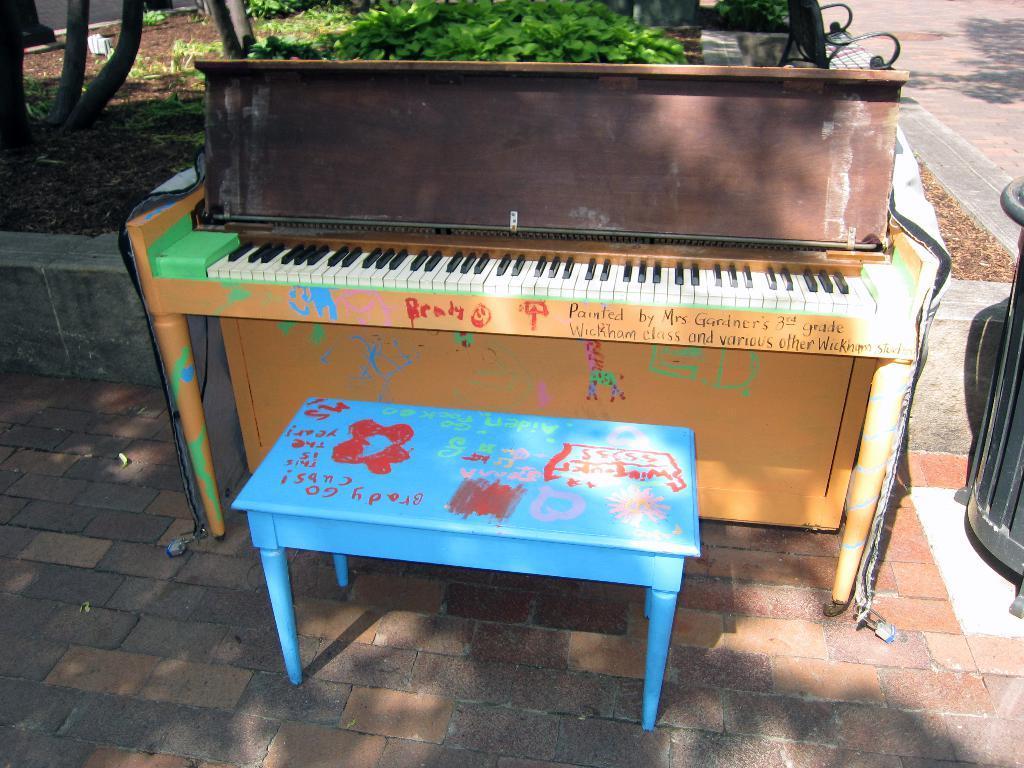Can you describe this image briefly? In this picture there is a piano, there is a chair in front of it. In the background there are plants, soil and on to the right there is a walk way 